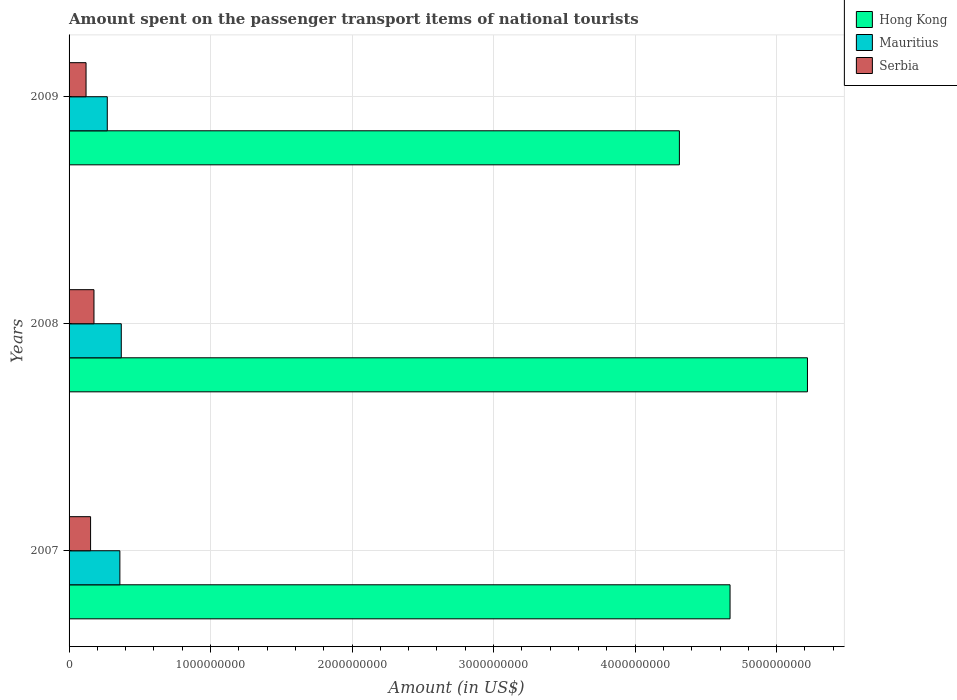How many groups of bars are there?
Provide a succinct answer. 3. Are the number of bars per tick equal to the number of legend labels?
Make the answer very short. Yes. How many bars are there on the 1st tick from the bottom?
Offer a terse response. 3. What is the label of the 1st group of bars from the top?
Make the answer very short. 2009. In how many cases, is the number of bars for a given year not equal to the number of legend labels?
Offer a very short reply. 0. What is the amount spent on the passenger transport items of national tourists in Serbia in 2007?
Your answer should be compact. 1.52e+08. Across all years, what is the maximum amount spent on the passenger transport items of national tourists in Serbia?
Offer a terse response. 1.76e+08. Across all years, what is the minimum amount spent on the passenger transport items of national tourists in Mauritius?
Give a very brief answer. 2.70e+08. What is the total amount spent on the passenger transport items of national tourists in Mauritius in the graph?
Your response must be concise. 9.98e+08. What is the difference between the amount spent on the passenger transport items of national tourists in Serbia in 2007 and that in 2009?
Keep it short and to the point. 3.20e+07. What is the difference between the amount spent on the passenger transport items of national tourists in Mauritius in 2009 and the amount spent on the passenger transport items of national tourists in Serbia in 2008?
Your response must be concise. 9.40e+07. What is the average amount spent on the passenger transport items of national tourists in Hong Kong per year?
Give a very brief answer. 4.73e+09. In the year 2008, what is the difference between the amount spent on the passenger transport items of national tourists in Serbia and amount spent on the passenger transport items of national tourists in Hong Kong?
Your answer should be very brief. -5.04e+09. In how many years, is the amount spent on the passenger transport items of national tourists in Mauritius greater than 2800000000 US$?
Your answer should be very brief. 0. What is the ratio of the amount spent on the passenger transport items of national tourists in Serbia in 2007 to that in 2009?
Provide a succinct answer. 1.27. Is the amount spent on the passenger transport items of national tourists in Mauritius in 2008 less than that in 2009?
Provide a short and direct response. No. Is the difference between the amount spent on the passenger transport items of national tourists in Serbia in 2008 and 2009 greater than the difference between the amount spent on the passenger transport items of national tourists in Hong Kong in 2008 and 2009?
Offer a terse response. No. What is the difference between the highest and the second highest amount spent on the passenger transport items of national tourists in Serbia?
Offer a very short reply. 2.40e+07. What is the difference between the highest and the lowest amount spent on the passenger transport items of national tourists in Serbia?
Provide a short and direct response. 5.60e+07. Is the sum of the amount spent on the passenger transport items of national tourists in Hong Kong in 2008 and 2009 greater than the maximum amount spent on the passenger transport items of national tourists in Serbia across all years?
Offer a terse response. Yes. What does the 3rd bar from the top in 2009 represents?
Keep it short and to the point. Hong Kong. What does the 2nd bar from the bottom in 2008 represents?
Provide a succinct answer. Mauritius. How many years are there in the graph?
Offer a terse response. 3. Are the values on the major ticks of X-axis written in scientific E-notation?
Your answer should be compact. No. What is the title of the graph?
Your answer should be compact. Amount spent on the passenger transport items of national tourists. What is the label or title of the X-axis?
Offer a very short reply. Amount (in US$). What is the Amount (in US$) in Hong Kong in 2007?
Offer a very short reply. 4.67e+09. What is the Amount (in US$) of Mauritius in 2007?
Offer a very short reply. 3.59e+08. What is the Amount (in US$) of Serbia in 2007?
Your answer should be very brief. 1.52e+08. What is the Amount (in US$) in Hong Kong in 2008?
Make the answer very short. 5.22e+09. What is the Amount (in US$) of Mauritius in 2008?
Give a very brief answer. 3.69e+08. What is the Amount (in US$) in Serbia in 2008?
Offer a very short reply. 1.76e+08. What is the Amount (in US$) in Hong Kong in 2009?
Offer a very short reply. 4.31e+09. What is the Amount (in US$) of Mauritius in 2009?
Give a very brief answer. 2.70e+08. What is the Amount (in US$) in Serbia in 2009?
Make the answer very short. 1.20e+08. Across all years, what is the maximum Amount (in US$) in Hong Kong?
Offer a very short reply. 5.22e+09. Across all years, what is the maximum Amount (in US$) in Mauritius?
Offer a very short reply. 3.69e+08. Across all years, what is the maximum Amount (in US$) in Serbia?
Offer a terse response. 1.76e+08. Across all years, what is the minimum Amount (in US$) of Hong Kong?
Your answer should be very brief. 4.31e+09. Across all years, what is the minimum Amount (in US$) in Mauritius?
Keep it short and to the point. 2.70e+08. Across all years, what is the minimum Amount (in US$) of Serbia?
Give a very brief answer. 1.20e+08. What is the total Amount (in US$) of Hong Kong in the graph?
Offer a very short reply. 1.42e+1. What is the total Amount (in US$) of Mauritius in the graph?
Provide a short and direct response. 9.98e+08. What is the total Amount (in US$) in Serbia in the graph?
Your response must be concise. 4.48e+08. What is the difference between the Amount (in US$) in Hong Kong in 2007 and that in 2008?
Keep it short and to the point. -5.47e+08. What is the difference between the Amount (in US$) in Mauritius in 2007 and that in 2008?
Offer a terse response. -1.00e+07. What is the difference between the Amount (in US$) of Serbia in 2007 and that in 2008?
Keep it short and to the point. -2.40e+07. What is the difference between the Amount (in US$) of Hong Kong in 2007 and that in 2009?
Your answer should be compact. 3.58e+08. What is the difference between the Amount (in US$) of Mauritius in 2007 and that in 2009?
Give a very brief answer. 8.90e+07. What is the difference between the Amount (in US$) of Serbia in 2007 and that in 2009?
Your response must be concise. 3.20e+07. What is the difference between the Amount (in US$) in Hong Kong in 2008 and that in 2009?
Provide a succinct answer. 9.05e+08. What is the difference between the Amount (in US$) in Mauritius in 2008 and that in 2009?
Give a very brief answer. 9.90e+07. What is the difference between the Amount (in US$) in Serbia in 2008 and that in 2009?
Offer a terse response. 5.60e+07. What is the difference between the Amount (in US$) of Hong Kong in 2007 and the Amount (in US$) of Mauritius in 2008?
Your response must be concise. 4.30e+09. What is the difference between the Amount (in US$) of Hong Kong in 2007 and the Amount (in US$) of Serbia in 2008?
Your response must be concise. 4.50e+09. What is the difference between the Amount (in US$) of Mauritius in 2007 and the Amount (in US$) of Serbia in 2008?
Make the answer very short. 1.83e+08. What is the difference between the Amount (in US$) in Hong Kong in 2007 and the Amount (in US$) in Mauritius in 2009?
Your answer should be compact. 4.40e+09. What is the difference between the Amount (in US$) in Hong Kong in 2007 and the Amount (in US$) in Serbia in 2009?
Make the answer very short. 4.55e+09. What is the difference between the Amount (in US$) of Mauritius in 2007 and the Amount (in US$) of Serbia in 2009?
Offer a very short reply. 2.39e+08. What is the difference between the Amount (in US$) of Hong Kong in 2008 and the Amount (in US$) of Mauritius in 2009?
Provide a short and direct response. 4.95e+09. What is the difference between the Amount (in US$) in Hong Kong in 2008 and the Amount (in US$) in Serbia in 2009?
Your answer should be compact. 5.10e+09. What is the difference between the Amount (in US$) in Mauritius in 2008 and the Amount (in US$) in Serbia in 2009?
Make the answer very short. 2.49e+08. What is the average Amount (in US$) in Hong Kong per year?
Your answer should be compact. 4.73e+09. What is the average Amount (in US$) in Mauritius per year?
Offer a very short reply. 3.33e+08. What is the average Amount (in US$) of Serbia per year?
Your answer should be very brief. 1.49e+08. In the year 2007, what is the difference between the Amount (in US$) of Hong Kong and Amount (in US$) of Mauritius?
Provide a succinct answer. 4.31e+09. In the year 2007, what is the difference between the Amount (in US$) in Hong Kong and Amount (in US$) in Serbia?
Your answer should be compact. 4.52e+09. In the year 2007, what is the difference between the Amount (in US$) in Mauritius and Amount (in US$) in Serbia?
Ensure brevity in your answer.  2.07e+08. In the year 2008, what is the difference between the Amount (in US$) of Hong Kong and Amount (in US$) of Mauritius?
Ensure brevity in your answer.  4.85e+09. In the year 2008, what is the difference between the Amount (in US$) in Hong Kong and Amount (in US$) in Serbia?
Ensure brevity in your answer.  5.04e+09. In the year 2008, what is the difference between the Amount (in US$) in Mauritius and Amount (in US$) in Serbia?
Ensure brevity in your answer.  1.93e+08. In the year 2009, what is the difference between the Amount (in US$) in Hong Kong and Amount (in US$) in Mauritius?
Your response must be concise. 4.04e+09. In the year 2009, what is the difference between the Amount (in US$) in Hong Kong and Amount (in US$) in Serbia?
Offer a terse response. 4.19e+09. In the year 2009, what is the difference between the Amount (in US$) in Mauritius and Amount (in US$) in Serbia?
Offer a very short reply. 1.50e+08. What is the ratio of the Amount (in US$) of Hong Kong in 2007 to that in 2008?
Your answer should be very brief. 0.9. What is the ratio of the Amount (in US$) in Mauritius in 2007 to that in 2008?
Your response must be concise. 0.97. What is the ratio of the Amount (in US$) in Serbia in 2007 to that in 2008?
Keep it short and to the point. 0.86. What is the ratio of the Amount (in US$) in Hong Kong in 2007 to that in 2009?
Your response must be concise. 1.08. What is the ratio of the Amount (in US$) in Mauritius in 2007 to that in 2009?
Provide a short and direct response. 1.33. What is the ratio of the Amount (in US$) of Serbia in 2007 to that in 2009?
Your answer should be compact. 1.27. What is the ratio of the Amount (in US$) of Hong Kong in 2008 to that in 2009?
Your answer should be compact. 1.21. What is the ratio of the Amount (in US$) of Mauritius in 2008 to that in 2009?
Offer a very short reply. 1.37. What is the ratio of the Amount (in US$) of Serbia in 2008 to that in 2009?
Provide a short and direct response. 1.47. What is the difference between the highest and the second highest Amount (in US$) of Hong Kong?
Your response must be concise. 5.47e+08. What is the difference between the highest and the second highest Amount (in US$) in Mauritius?
Ensure brevity in your answer.  1.00e+07. What is the difference between the highest and the second highest Amount (in US$) of Serbia?
Make the answer very short. 2.40e+07. What is the difference between the highest and the lowest Amount (in US$) of Hong Kong?
Offer a very short reply. 9.05e+08. What is the difference between the highest and the lowest Amount (in US$) of Mauritius?
Your response must be concise. 9.90e+07. What is the difference between the highest and the lowest Amount (in US$) of Serbia?
Give a very brief answer. 5.60e+07. 